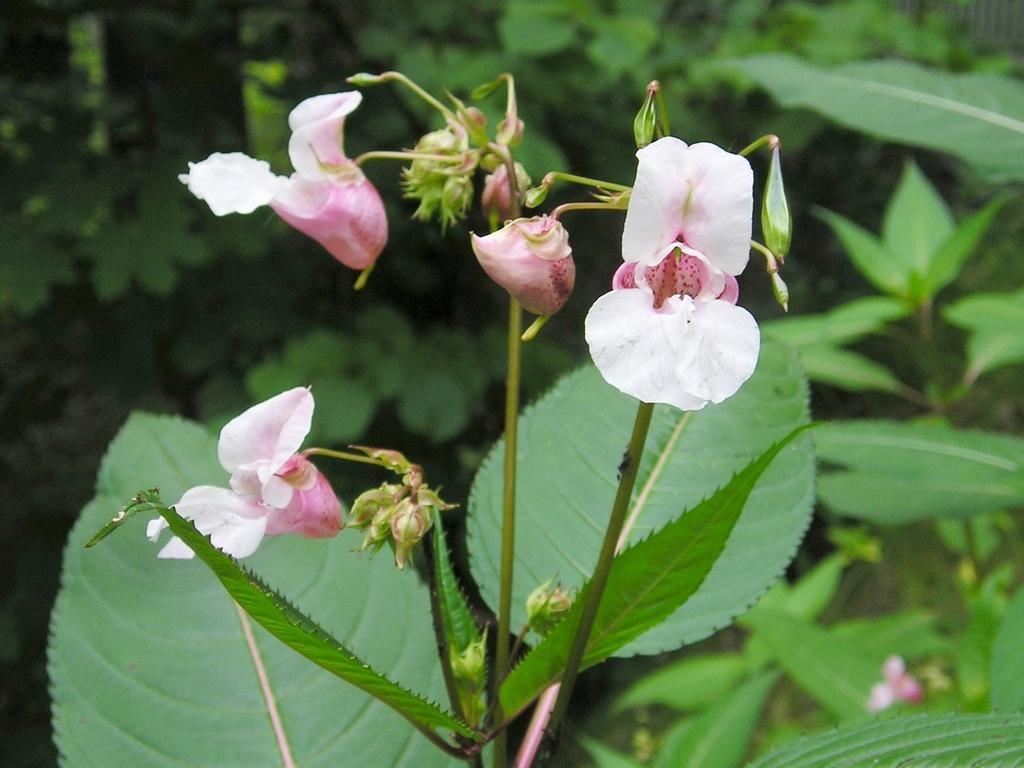What is the main subject of the image? The main subject of the image is plants. Can you describe the plants in the image? There are there any specific features? How many sisters are present in the image? There are no sisters present in the image; it features plants with flowers. Can you describe the bee or insect interacting with the flowers in the image? There is no bee or insect present in the image; it only features plants with flowers. 